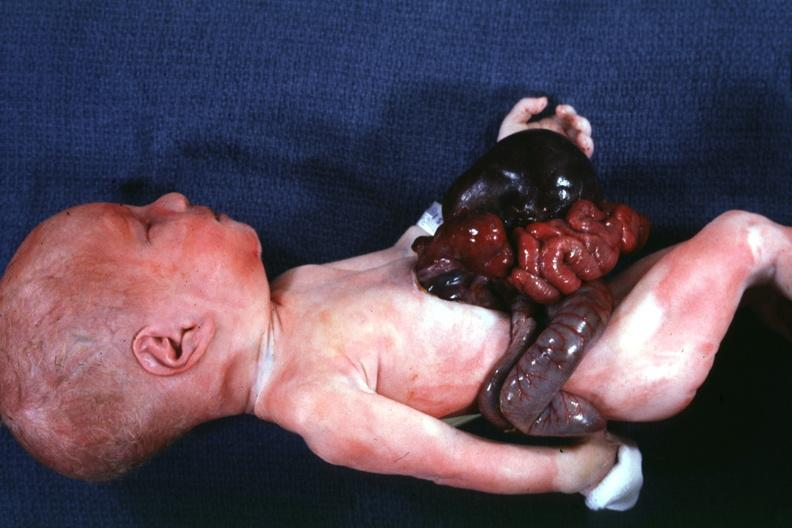what is present?
Answer the question using a single word or phrase. Abdomen 